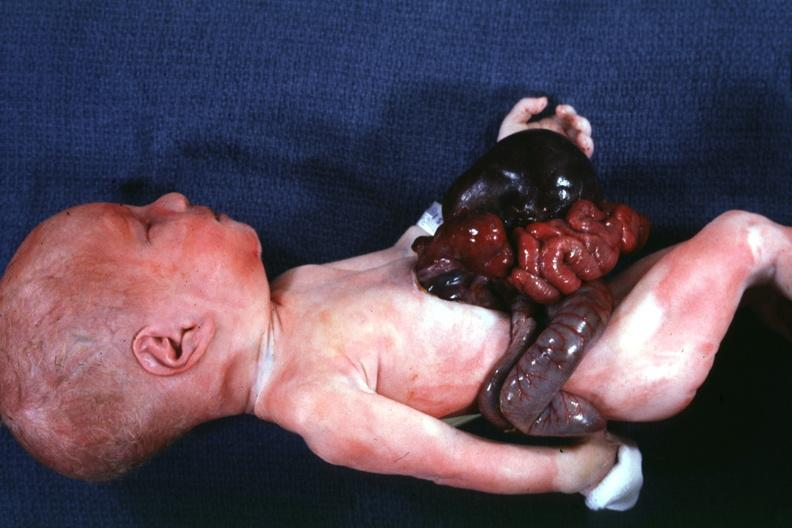what is present?
Answer the question using a single word or phrase. Abdomen 